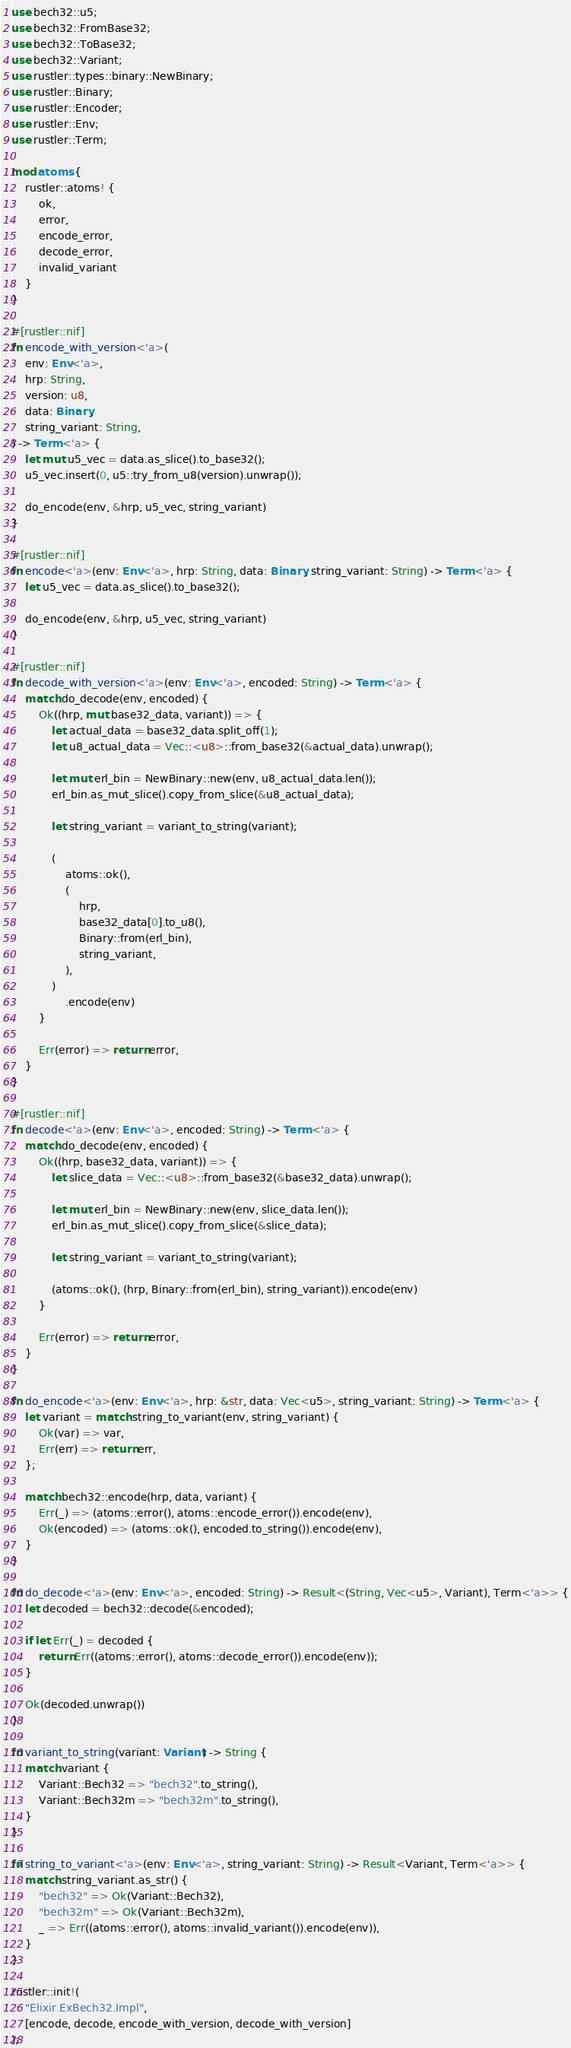<code> <loc_0><loc_0><loc_500><loc_500><_Rust_>use bech32::u5;
use bech32::FromBase32;
use bech32::ToBase32;
use bech32::Variant;
use rustler::types::binary::NewBinary;
use rustler::Binary;
use rustler::Encoder;
use rustler::Env;
use rustler::Term;

mod atoms {
    rustler::atoms! {
        ok,
        error,
        encode_error,
        decode_error,
        invalid_variant
    }
}

#[rustler::nif]
fn encode_with_version<'a>(
    env: Env<'a>,
    hrp: String,
    version: u8,
    data: Binary,
    string_variant: String,
) -> Term<'a> {
    let mut u5_vec = data.as_slice().to_base32();
    u5_vec.insert(0, u5::try_from_u8(version).unwrap());

    do_encode(env, &hrp, u5_vec, string_variant)
}

#[rustler::nif]
fn encode<'a>(env: Env<'a>, hrp: String, data: Binary, string_variant: String) -> Term<'a> {
    let u5_vec = data.as_slice().to_base32();

    do_encode(env, &hrp, u5_vec, string_variant)
}

#[rustler::nif]
fn decode_with_version<'a>(env: Env<'a>, encoded: String) -> Term<'a> {
    match do_decode(env, encoded) {
        Ok((hrp, mut base32_data, variant)) => {
            let actual_data = base32_data.split_off(1);
            let u8_actual_data = Vec::<u8>::from_base32(&actual_data).unwrap();

            let mut erl_bin = NewBinary::new(env, u8_actual_data.len());
            erl_bin.as_mut_slice().copy_from_slice(&u8_actual_data);

            let string_variant = variant_to_string(variant);

            (
                atoms::ok(),
                (
                    hrp,
                    base32_data[0].to_u8(),
                    Binary::from(erl_bin),
                    string_variant,
                ),
            )
                .encode(env)
        }

        Err(error) => return error,
    }
}

#[rustler::nif]
fn decode<'a>(env: Env<'a>, encoded: String) -> Term<'a> {
    match do_decode(env, encoded) {
        Ok((hrp, base32_data, variant)) => {
            let slice_data = Vec::<u8>::from_base32(&base32_data).unwrap();

            let mut erl_bin = NewBinary::new(env, slice_data.len());
            erl_bin.as_mut_slice().copy_from_slice(&slice_data);

            let string_variant = variant_to_string(variant);

            (atoms::ok(), (hrp, Binary::from(erl_bin), string_variant)).encode(env)
        }

        Err(error) => return error,
    }
}

fn do_encode<'a>(env: Env<'a>, hrp: &str, data: Vec<u5>, string_variant: String) -> Term<'a> {
    let variant = match string_to_variant(env, string_variant) {
        Ok(var) => var,
        Err(err) => return err,
    };

    match bech32::encode(hrp, data, variant) {
        Err(_) => (atoms::error(), atoms::encode_error()).encode(env),
        Ok(encoded) => (atoms::ok(), encoded.to_string()).encode(env),
    }
}

fn do_decode<'a>(env: Env<'a>, encoded: String) -> Result<(String, Vec<u5>, Variant), Term<'a>> {
    let decoded = bech32::decode(&encoded);

    if let Err(_) = decoded {
        return Err((atoms::error(), atoms::decode_error()).encode(env));
    }

    Ok(decoded.unwrap())
}

fn variant_to_string(variant: Variant) -> String {
    match variant {
        Variant::Bech32 => "bech32".to_string(),
        Variant::Bech32m => "bech32m".to_string(),
    }
}

fn string_to_variant<'a>(env: Env<'a>, string_variant: String) -> Result<Variant, Term<'a>> {
    match string_variant.as_str() {
        "bech32" => Ok(Variant::Bech32),
        "bech32m" => Ok(Variant::Bech32m),
        _ => Err((atoms::error(), atoms::invalid_variant()).encode(env)),
    }
}

rustler::init!(
    "Elixir.ExBech32.Impl",
    [encode, decode, encode_with_version, decode_with_version]
);
</code> 